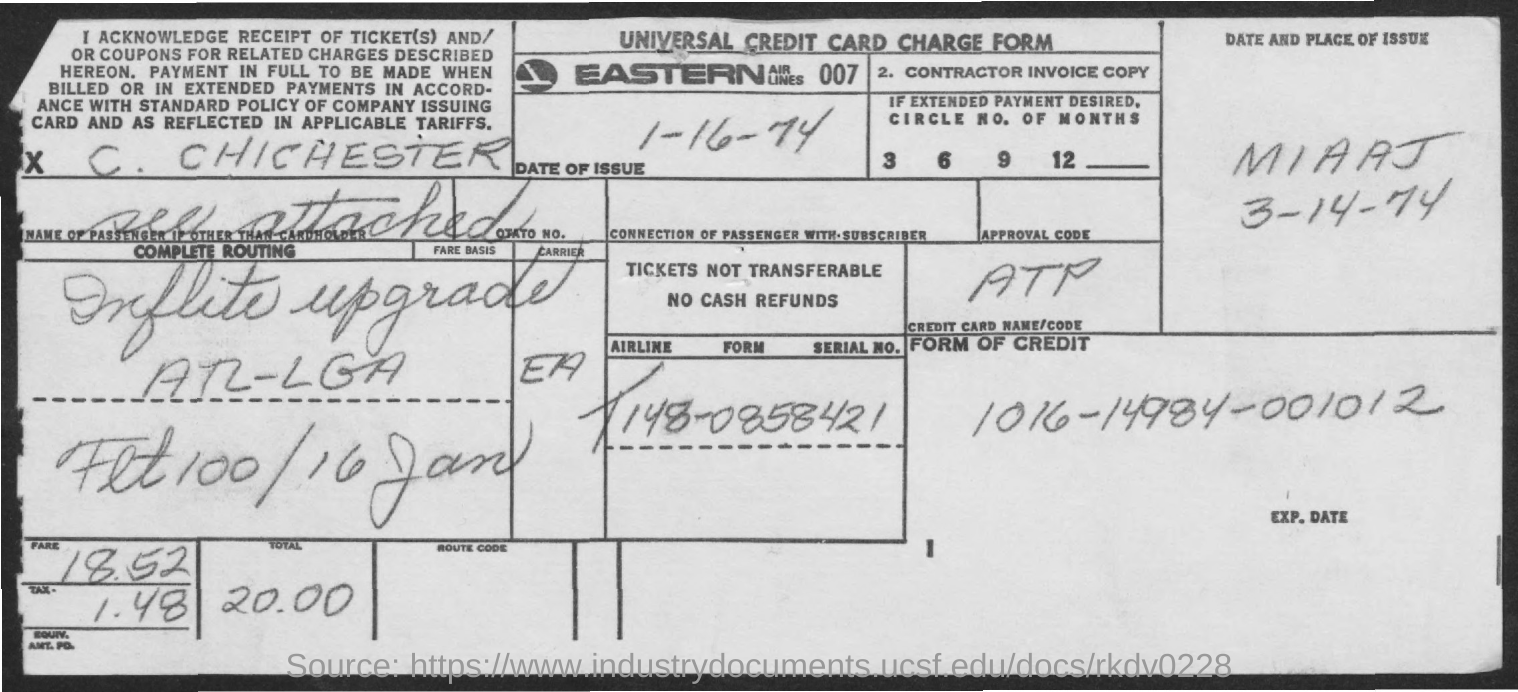Highlight a few significant elements in this photo. The total fare is 20.00," the representative declared. The form of credit is 1016-14984-001012. The title of the given document is Universal Credit Card Charge Form. 